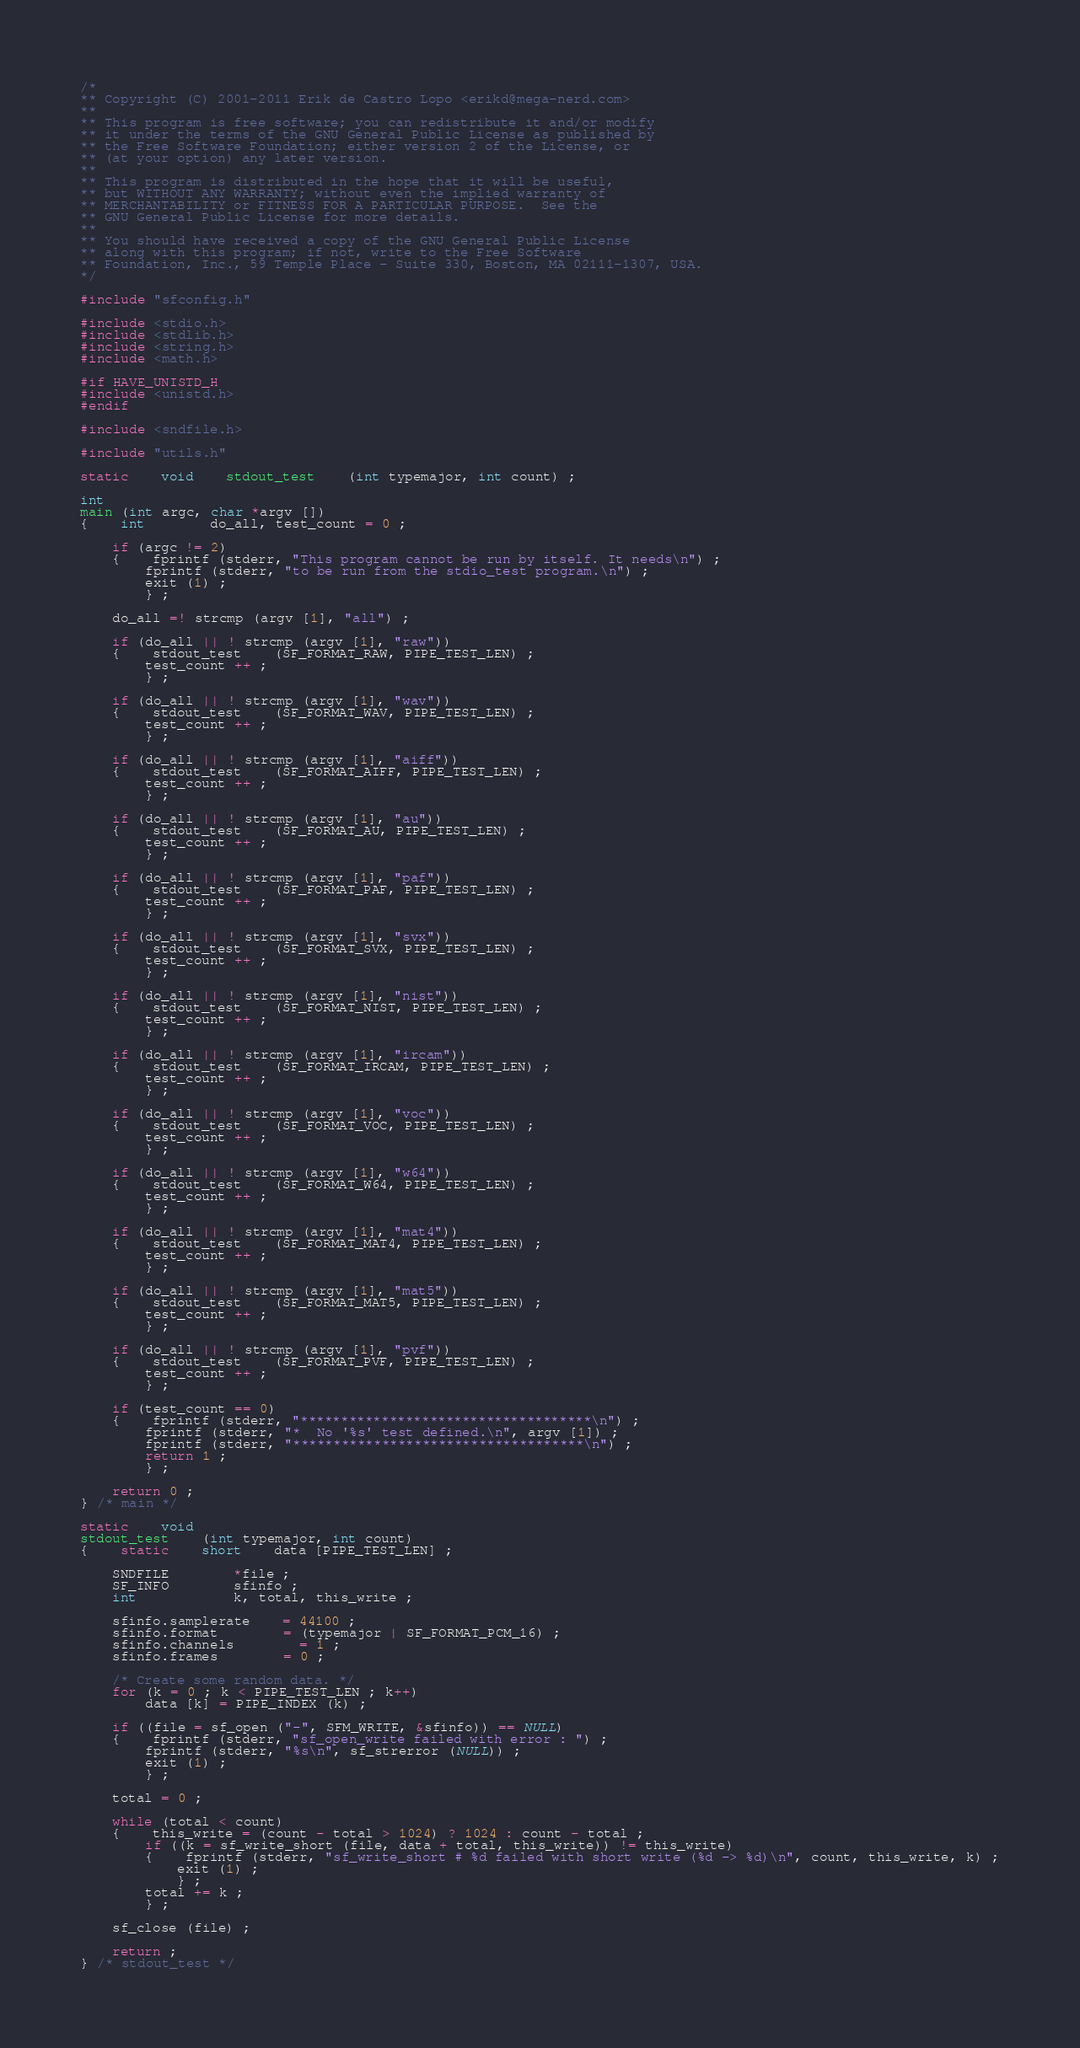<code> <loc_0><loc_0><loc_500><loc_500><_C_>/*
** Copyright (C) 2001-2011 Erik de Castro Lopo <erikd@mega-nerd.com>
**
** This program is free software; you can redistribute it and/or modify
** it under the terms of the GNU General Public License as published by
** the Free Software Foundation; either version 2 of the License, or
** (at your option) any later version.
**
** This program is distributed in the hope that it will be useful,
** but WITHOUT ANY WARRANTY; without even the implied warranty of
** MERCHANTABILITY or FITNESS FOR A PARTICULAR PURPOSE.  See the
** GNU General Public License for more details.
**
** You should have received a copy of the GNU General Public License
** along with this program; if not, write to the Free Software
** Foundation, Inc., 59 Temple Place - Suite 330, Boston, MA 02111-1307, USA.
*/

#include "sfconfig.h"

#include <stdio.h>
#include <stdlib.h>
#include <string.h>
#include <math.h>

#if HAVE_UNISTD_H
#include <unistd.h>
#endif

#include <sndfile.h>

#include "utils.h"

static	void	stdout_test	(int typemajor, int count) ;

int
main (int argc, char *argv [])
{	int		do_all, test_count = 0 ;

	if (argc != 2)
	{	fprintf (stderr, "This program cannot be run by itself. It needs\n") ;
		fprintf (stderr, "to be run from the stdio_test program.\n") ;
		exit (1) ;
		} ;

	do_all =! strcmp (argv [1], "all") ;

	if (do_all || ! strcmp (argv [1], "raw"))
	{	stdout_test	(SF_FORMAT_RAW, PIPE_TEST_LEN) ;
		test_count ++ ;
		} ;

	if (do_all || ! strcmp (argv [1], "wav"))
	{	stdout_test	(SF_FORMAT_WAV, PIPE_TEST_LEN) ;
		test_count ++ ;
		} ;

	if (do_all || ! strcmp (argv [1], "aiff"))
	{	stdout_test	(SF_FORMAT_AIFF, PIPE_TEST_LEN) ;
		test_count ++ ;
		} ;

	if (do_all || ! strcmp (argv [1], "au"))
	{	stdout_test	(SF_FORMAT_AU, PIPE_TEST_LEN) ;
		test_count ++ ;
		} ;

	if (do_all || ! strcmp (argv [1], "paf"))
	{	stdout_test	(SF_FORMAT_PAF, PIPE_TEST_LEN) ;
		test_count ++ ;
		} ;

	if (do_all || ! strcmp (argv [1], "svx"))
	{	stdout_test	(SF_FORMAT_SVX, PIPE_TEST_LEN) ;
		test_count ++ ;
		} ;

	if (do_all || ! strcmp (argv [1], "nist"))
	{	stdout_test	(SF_FORMAT_NIST, PIPE_TEST_LEN) ;
		test_count ++ ;
		} ;

	if (do_all || ! strcmp (argv [1], "ircam"))
	{	stdout_test	(SF_FORMAT_IRCAM, PIPE_TEST_LEN) ;
		test_count ++ ;
		} ;

	if (do_all || ! strcmp (argv [1], "voc"))
	{	stdout_test	(SF_FORMAT_VOC, PIPE_TEST_LEN) ;
		test_count ++ ;
		} ;

	if (do_all || ! strcmp (argv [1], "w64"))
	{	stdout_test	(SF_FORMAT_W64, PIPE_TEST_LEN) ;
		test_count ++ ;
		} ;

	if (do_all || ! strcmp (argv [1], "mat4"))
	{	stdout_test	(SF_FORMAT_MAT4, PIPE_TEST_LEN) ;
		test_count ++ ;
		} ;

	if (do_all || ! strcmp (argv [1], "mat5"))
	{	stdout_test	(SF_FORMAT_MAT5, PIPE_TEST_LEN) ;
		test_count ++ ;
		} ;

	if (do_all || ! strcmp (argv [1], "pvf"))
	{	stdout_test	(SF_FORMAT_PVF, PIPE_TEST_LEN) ;
		test_count ++ ;
		} ;

	if (test_count == 0)
	{	fprintf (stderr, "************************************\n") ;
		fprintf (stderr, "*  No '%s' test defined.\n", argv [1]) ;
		fprintf (stderr, "************************************\n") ;
		return 1 ;
		} ;

	return 0 ;
} /* main */

static	void
stdout_test	(int typemajor, int count)
{	static	short	data [PIPE_TEST_LEN] ;

	SNDFILE		*file ;
	SF_INFO		sfinfo ;
	int			k, total, this_write ;

	sfinfo.samplerate	= 44100 ;
	sfinfo.format		= (typemajor | SF_FORMAT_PCM_16) ;
	sfinfo.channels		= 1 ;
	sfinfo.frames		= 0 ;

	/* Create some random data. */
	for (k = 0 ; k < PIPE_TEST_LEN ; k++)
		data [k] = PIPE_INDEX (k) ;

	if ((file = sf_open ("-", SFM_WRITE, &sfinfo)) == NULL)
	{	fprintf (stderr, "sf_open_write failed with error : ") ;
		fprintf (stderr, "%s\n", sf_strerror (NULL)) ;
		exit (1) ;
		} ;

	total = 0 ;

	while (total < count)
	{	this_write = (count - total > 1024) ? 1024 : count - total ;
		if ((k = sf_write_short (file, data + total, this_write)) != this_write)
		{	fprintf (stderr, "sf_write_short # %d failed with short write (%d -> %d)\n", count, this_write, k) ;
			exit (1) ;
			} ;
		total += k ;
		} ;

	sf_close (file) ;

	return ;
} /* stdout_test */

</code> 